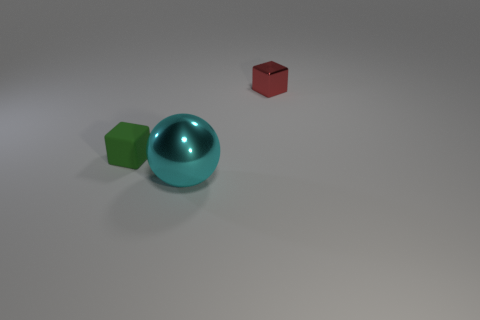The metallic ball has what size?
Make the answer very short. Large. How big is the object that is both in front of the red block and behind the big sphere?
Your response must be concise. Small. What shape is the thing behind the small matte object?
Your response must be concise. Cube. Do the cyan thing and the tiny block that is right of the cyan ball have the same material?
Offer a very short reply. Yes. Does the green rubber thing have the same shape as the tiny red object?
Ensure brevity in your answer.  Yes. What material is the other small thing that is the same shape as the tiny metal object?
Your answer should be very brief. Rubber. What is the color of the object that is right of the green matte block and behind the ball?
Offer a very short reply. Red. What color is the big shiny sphere?
Make the answer very short. Cyan. Are there any other big things of the same shape as the cyan metallic thing?
Keep it short and to the point. No. There is a object right of the big cyan ball; how big is it?
Give a very brief answer. Small. 